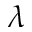<formula> <loc_0><loc_0><loc_500><loc_500>\lambda</formula> 